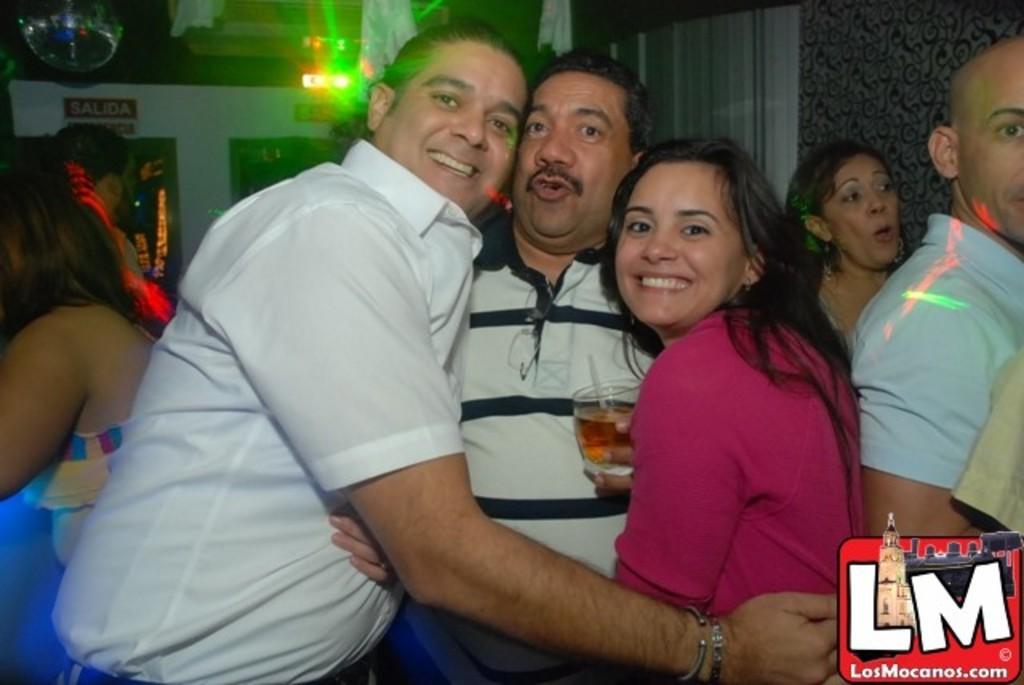How would you summarize this image in a sentence or two? In this image we can see a group of people standing. One man is holding a glass in his hand. In the background, we can see a board with some text. At the top of the image we can see some clothes and lights. 